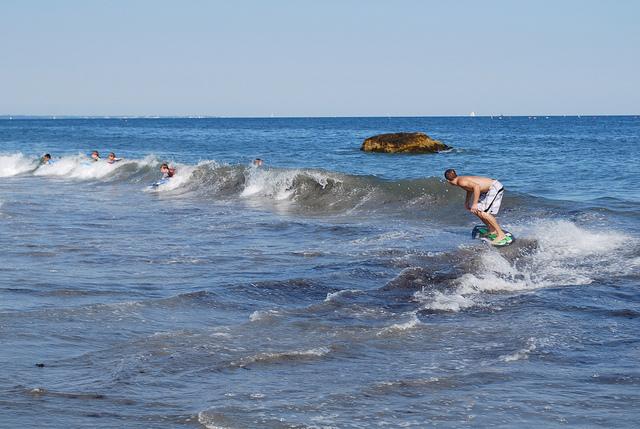How many people are in the water?
Short answer required. 6. Is the water deep?
Give a very brief answer. Yes. What is the person wearing on their upper torso?
Keep it brief. Nothing. What color is the water?
Answer briefly. Blue. How many people are in the photo?
Keep it brief. 6. Are all these people surfing?
Quick response, please. Yes. What is this man wearing?
Quick response, please. Swim trunks. What animal is in the water?
Write a very short answer. Human. Will the surfing man make it out to the horizon?
Keep it brief. No. 